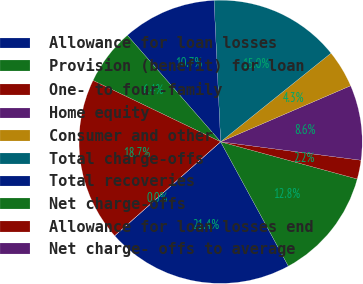<chart> <loc_0><loc_0><loc_500><loc_500><pie_chart><fcel>Allowance for loan losses<fcel>Provision (benefit) for loan<fcel>One- to four-family<fcel>Home equity<fcel>Consumer and other<fcel>Total charge-offs<fcel>Total recoveries<fcel>Net charge-offs<fcel>Allowance for loan losses end<fcel>Net charge- offs to average<nl><fcel>21.38%<fcel>12.83%<fcel>2.15%<fcel>8.56%<fcel>4.29%<fcel>14.97%<fcel>10.7%<fcel>6.42%<fcel>18.68%<fcel>0.01%<nl></chart> 